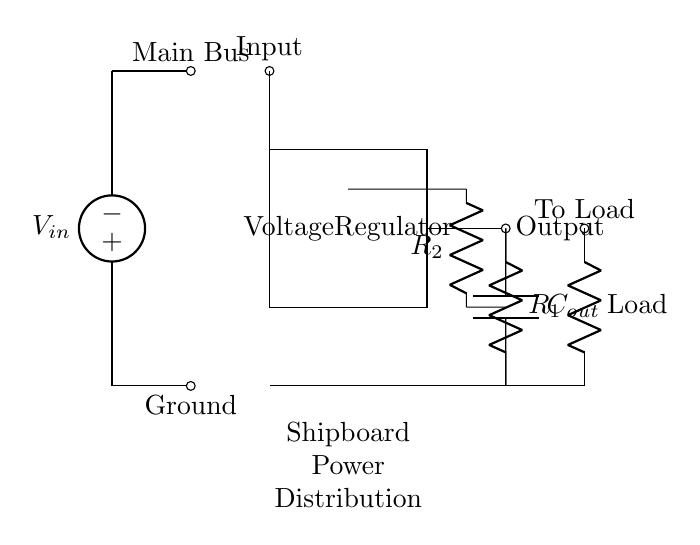What is the input voltage of the circuit? The input voltage is represented by the voltage source labeled as V_in at the top of the circuit diagram. It is the initial source of power for the voltage regulation process.
Answer: V_in What is the function of the voltage regulator? The voltage regulator's role is to maintain a consistent output voltage despite variations in input voltage or load conditions, as shown in the rectangular shape labeled “Voltage Regulator.”
Answer: To regulate voltage Which component determines the output load in the circuit? The load is represented by a resistor labeled as Load at the right side of the circuit, indicating that it consumes the regulated output voltage provided by the regulator.
Answer: Resistor What happens to the voltage after passing through the voltage regulator? After passing through the voltage regulator, the voltage is maintained at a steady level, which can be seen as the output that connects to the Load, ensuring its consistency for shipboard applications.
Answer: Steady voltage What type of feedback components are used in this circuit? The feedback loop uses two resistors labeled as R1 and R2, enabling the regulator to sample the output voltage and adjust it accordingly for stability. This setup is essential for maintaining voltage regulation by forming a voltage divider.
Answer: Resistors How does the output capacitor influence the circuit? The output capacitor, labeled as C_out, acts to smooth out any fluctuations in the output signal, reducing ripple and ensuring stable voltage to the load by providing charge during sudden demands.
Answer: Smoothing effect 